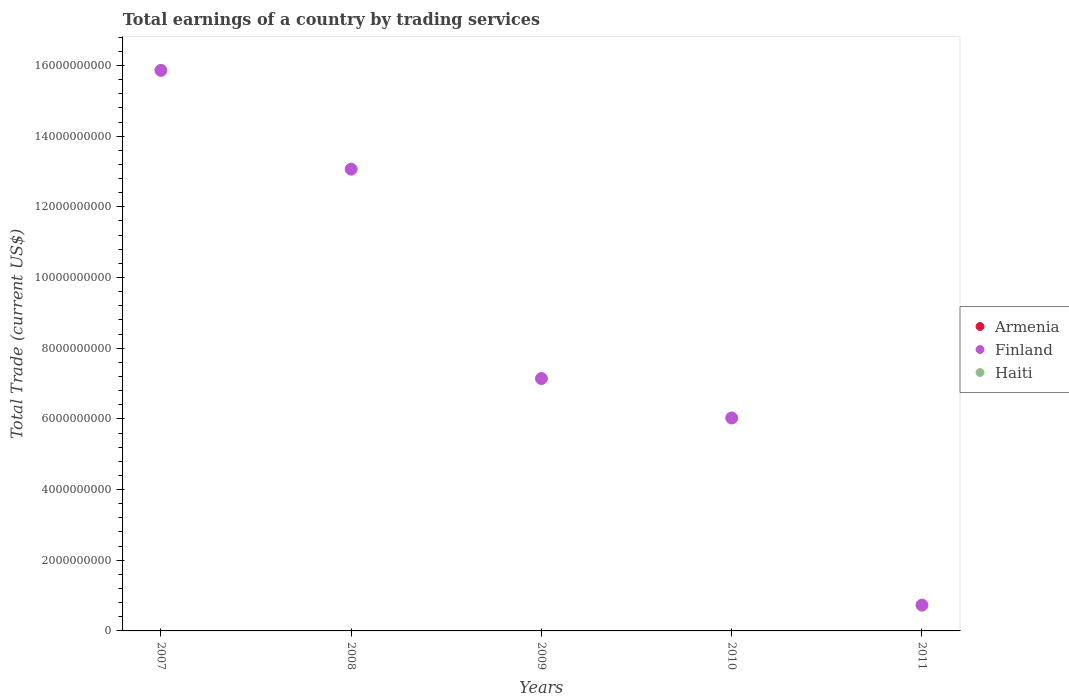What is the total earnings in Haiti in 2010?
Ensure brevity in your answer.  0. Across all years, what is the maximum total earnings in Finland?
Make the answer very short. 1.59e+1. Across all years, what is the minimum total earnings in Finland?
Make the answer very short. 7.30e+08. In which year was the total earnings in Finland maximum?
Give a very brief answer. 2007. What is the total total earnings in Armenia in the graph?
Your response must be concise. 0. What is the difference between the total earnings in Finland in 2009 and that in 2011?
Ensure brevity in your answer.  6.41e+09. What is the difference between the total earnings in Haiti in 2011 and the total earnings in Armenia in 2010?
Ensure brevity in your answer.  0. What is the ratio of the total earnings in Finland in 2007 to that in 2011?
Offer a very short reply. 21.74. Is the total earnings in Finland in 2007 less than that in 2010?
Provide a succinct answer. No. What is the difference between the highest and the second highest total earnings in Finland?
Give a very brief answer. 2.79e+09. What is the difference between the highest and the lowest total earnings in Finland?
Your response must be concise. 1.51e+1. Is it the case that in every year, the sum of the total earnings in Haiti and total earnings in Finland  is greater than the total earnings in Armenia?
Offer a very short reply. Yes. Does the total earnings in Armenia monotonically increase over the years?
Give a very brief answer. No. Is the total earnings in Haiti strictly greater than the total earnings in Armenia over the years?
Make the answer very short. No. Is the total earnings in Armenia strictly less than the total earnings in Haiti over the years?
Offer a terse response. No. How many dotlines are there?
Your answer should be compact. 1. Are the values on the major ticks of Y-axis written in scientific E-notation?
Your answer should be compact. No. Does the graph contain any zero values?
Offer a terse response. Yes. What is the title of the graph?
Your answer should be very brief. Total earnings of a country by trading services. What is the label or title of the X-axis?
Provide a succinct answer. Years. What is the label or title of the Y-axis?
Your answer should be very brief. Total Trade (current US$). What is the Total Trade (current US$) of Finland in 2007?
Your response must be concise. 1.59e+1. What is the Total Trade (current US$) in Armenia in 2008?
Ensure brevity in your answer.  0. What is the Total Trade (current US$) in Finland in 2008?
Provide a succinct answer. 1.31e+1. What is the Total Trade (current US$) of Finland in 2009?
Make the answer very short. 7.14e+09. What is the Total Trade (current US$) in Haiti in 2009?
Provide a short and direct response. 0. What is the Total Trade (current US$) of Armenia in 2010?
Provide a succinct answer. 0. What is the Total Trade (current US$) in Finland in 2010?
Ensure brevity in your answer.  6.03e+09. What is the Total Trade (current US$) of Haiti in 2010?
Ensure brevity in your answer.  0. What is the Total Trade (current US$) in Finland in 2011?
Keep it short and to the point. 7.30e+08. What is the Total Trade (current US$) in Haiti in 2011?
Provide a succinct answer. 0. Across all years, what is the maximum Total Trade (current US$) of Finland?
Keep it short and to the point. 1.59e+1. Across all years, what is the minimum Total Trade (current US$) of Finland?
Provide a succinct answer. 7.30e+08. What is the total Total Trade (current US$) of Finland in the graph?
Make the answer very short. 4.28e+1. What is the total Total Trade (current US$) of Haiti in the graph?
Keep it short and to the point. 0. What is the difference between the Total Trade (current US$) in Finland in 2007 and that in 2008?
Your answer should be very brief. 2.79e+09. What is the difference between the Total Trade (current US$) in Finland in 2007 and that in 2009?
Keep it short and to the point. 8.72e+09. What is the difference between the Total Trade (current US$) of Finland in 2007 and that in 2010?
Offer a terse response. 9.83e+09. What is the difference between the Total Trade (current US$) of Finland in 2007 and that in 2011?
Provide a succinct answer. 1.51e+1. What is the difference between the Total Trade (current US$) of Finland in 2008 and that in 2009?
Offer a very short reply. 5.92e+09. What is the difference between the Total Trade (current US$) of Finland in 2008 and that in 2010?
Your answer should be very brief. 7.04e+09. What is the difference between the Total Trade (current US$) in Finland in 2008 and that in 2011?
Offer a very short reply. 1.23e+1. What is the difference between the Total Trade (current US$) in Finland in 2009 and that in 2010?
Your answer should be compact. 1.12e+09. What is the difference between the Total Trade (current US$) in Finland in 2009 and that in 2011?
Your answer should be compact. 6.41e+09. What is the difference between the Total Trade (current US$) in Finland in 2010 and that in 2011?
Offer a terse response. 5.30e+09. What is the average Total Trade (current US$) of Finland per year?
Your response must be concise. 8.56e+09. What is the ratio of the Total Trade (current US$) of Finland in 2007 to that in 2008?
Offer a terse response. 1.21. What is the ratio of the Total Trade (current US$) of Finland in 2007 to that in 2009?
Provide a short and direct response. 2.22. What is the ratio of the Total Trade (current US$) in Finland in 2007 to that in 2010?
Provide a succinct answer. 2.63. What is the ratio of the Total Trade (current US$) in Finland in 2007 to that in 2011?
Offer a very short reply. 21.74. What is the ratio of the Total Trade (current US$) of Finland in 2008 to that in 2009?
Offer a terse response. 1.83. What is the ratio of the Total Trade (current US$) in Finland in 2008 to that in 2010?
Provide a succinct answer. 2.17. What is the ratio of the Total Trade (current US$) in Finland in 2008 to that in 2011?
Your response must be concise. 17.91. What is the ratio of the Total Trade (current US$) in Finland in 2009 to that in 2010?
Your answer should be compact. 1.19. What is the ratio of the Total Trade (current US$) of Finland in 2009 to that in 2011?
Provide a succinct answer. 9.79. What is the ratio of the Total Trade (current US$) of Finland in 2010 to that in 2011?
Provide a short and direct response. 8.26. What is the difference between the highest and the second highest Total Trade (current US$) in Finland?
Offer a terse response. 2.79e+09. What is the difference between the highest and the lowest Total Trade (current US$) in Finland?
Keep it short and to the point. 1.51e+1. 